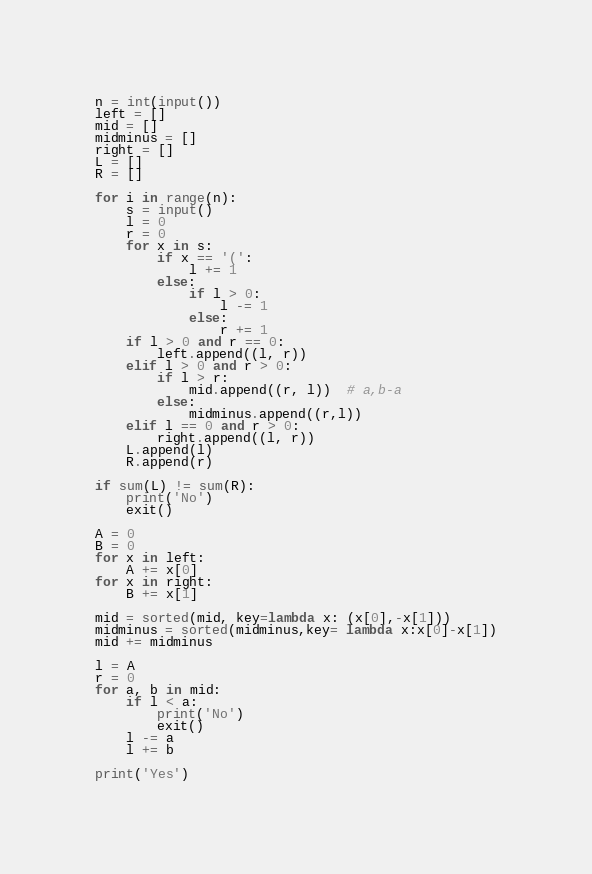<code> <loc_0><loc_0><loc_500><loc_500><_Python_>n = int(input())
left = []
mid = []
midminus = []
right = []
L = []
R = []

for i in range(n):
    s = input()
    l = 0
    r = 0
    for x in s:
        if x == '(':
            l += 1
        else:
            if l > 0:
                l -= 1
            else:
                r += 1
    if l > 0 and r == 0:
        left.append((l, r))
    elif l > 0 and r > 0:
        if l > r:
            mid.append((r, l))  # a,b-a
        else:
            midminus.append((r,l))
    elif l == 0 and r > 0:
        right.append((l, r))
    L.append(l)
    R.append(r)

if sum(L) != sum(R):
    print('No')
    exit()

A = 0
B = 0
for x in left:
    A += x[0]
for x in right:
    B += x[1]

mid = sorted(mid, key=lambda x: (x[0],-x[1]))
midminus = sorted(midminus,key= lambda x:x[0]-x[1])
mid += midminus

l = A
r = 0
for a, b in mid:
    if l < a:
        print('No')
        exit()
    l -= a
    l += b

print('Yes')</code> 